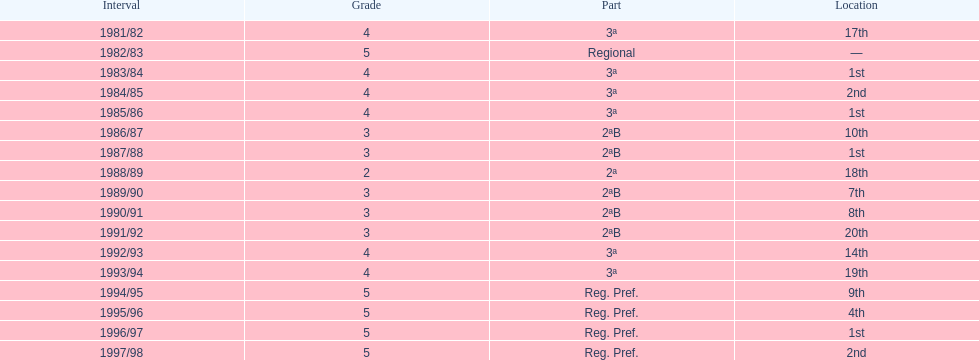Could you help me parse every detail presented in this table? {'header': ['Interval', 'Grade', 'Part', 'Location'], 'rows': [['1981/82', '4', '3ª', '17th'], ['1982/83', '5', 'Regional', '—'], ['1983/84', '4', '3ª', '1st'], ['1984/85', '4', '3ª', '2nd'], ['1985/86', '4', '3ª', '1st'], ['1986/87', '3', '2ªB', '10th'], ['1987/88', '3', '2ªB', '1st'], ['1988/89', '2', '2ª', '18th'], ['1989/90', '3', '2ªB', '7th'], ['1990/91', '3', '2ªB', '8th'], ['1991/92', '3', '2ªB', '20th'], ['1992/93', '4', '3ª', '14th'], ['1993/94', '4', '3ª', '19th'], ['1994/95', '5', 'Reg. Pref.', '9th'], ['1995/96', '5', 'Reg. Pref.', '4th'], ['1996/97', '5', 'Reg. Pref.', '1st'], ['1997/98', '5', 'Reg. Pref.', '2nd']]} In how many instances did they achieve the first place finish? 4. 